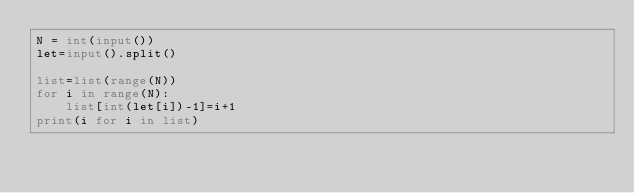Convert code to text. <code><loc_0><loc_0><loc_500><loc_500><_Python_>N = int(input())
let=input().split()

list=list(range(N))
for i in range(N):
    list[int(let[i])-1]=i+1
print(i for i in list)
</code> 